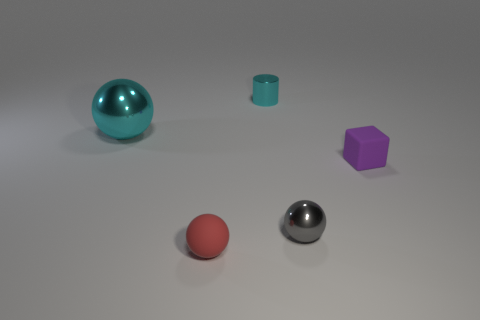Add 2 small red spheres. How many objects exist? 7 Subtract all balls. How many objects are left? 2 Add 5 small gray things. How many small gray things exist? 6 Subtract 1 purple cubes. How many objects are left? 4 Subtract all large brown matte things. Subtract all tiny cyan things. How many objects are left? 4 Add 5 matte spheres. How many matte spheres are left? 6 